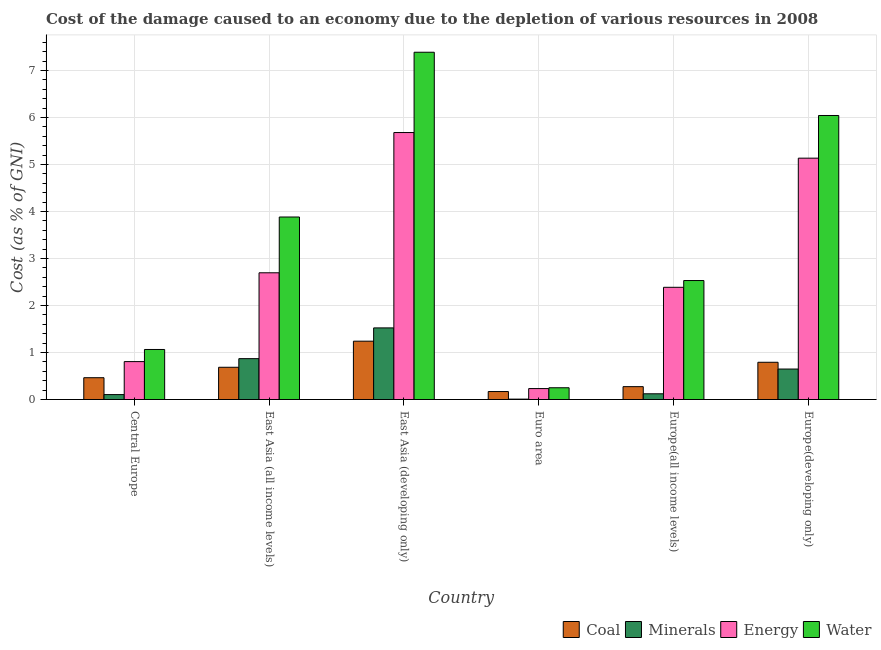How many different coloured bars are there?
Make the answer very short. 4. How many groups of bars are there?
Offer a terse response. 6. Are the number of bars on each tick of the X-axis equal?
Ensure brevity in your answer.  Yes. How many bars are there on the 5th tick from the right?
Make the answer very short. 4. What is the label of the 5th group of bars from the left?
Ensure brevity in your answer.  Europe(all income levels). What is the cost of damage due to depletion of energy in Central Europe?
Provide a succinct answer. 0.81. Across all countries, what is the maximum cost of damage due to depletion of energy?
Your answer should be very brief. 5.68. Across all countries, what is the minimum cost of damage due to depletion of minerals?
Provide a short and direct response. 0.01. In which country was the cost of damage due to depletion of energy maximum?
Keep it short and to the point. East Asia (developing only). In which country was the cost of damage due to depletion of coal minimum?
Offer a very short reply. Euro area. What is the total cost of damage due to depletion of energy in the graph?
Give a very brief answer. 16.94. What is the difference between the cost of damage due to depletion of energy in East Asia (all income levels) and that in Europe(developing only)?
Your response must be concise. -2.44. What is the difference between the cost of damage due to depletion of water in East Asia (developing only) and the cost of damage due to depletion of coal in Europe(developing only)?
Give a very brief answer. 6.6. What is the average cost of damage due to depletion of minerals per country?
Make the answer very short. 0.55. What is the difference between the cost of damage due to depletion of minerals and cost of damage due to depletion of water in Europe(all income levels)?
Provide a short and direct response. -2.41. In how many countries, is the cost of damage due to depletion of minerals greater than 0.8 %?
Your answer should be compact. 2. What is the ratio of the cost of damage due to depletion of coal in East Asia (developing only) to that in Europe(developing only)?
Provide a short and direct response. 1.57. Is the difference between the cost of damage due to depletion of minerals in East Asia (developing only) and Europe(all income levels) greater than the difference between the cost of damage due to depletion of water in East Asia (developing only) and Europe(all income levels)?
Your response must be concise. No. What is the difference between the highest and the second highest cost of damage due to depletion of coal?
Ensure brevity in your answer.  0.45. What is the difference between the highest and the lowest cost of damage due to depletion of coal?
Your answer should be compact. 1.07. Is the sum of the cost of damage due to depletion of coal in Central Europe and East Asia (all income levels) greater than the maximum cost of damage due to depletion of minerals across all countries?
Provide a short and direct response. No. Is it the case that in every country, the sum of the cost of damage due to depletion of coal and cost of damage due to depletion of energy is greater than the sum of cost of damage due to depletion of water and cost of damage due to depletion of minerals?
Give a very brief answer. No. What does the 3rd bar from the left in East Asia (developing only) represents?
Provide a short and direct response. Energy. What does the 4th bar from the right in East Asia (all income levels) represents?
Keep it short and to the point. Coal. Is it the case that in every country, the sum of the cost of damage due to depletion of coal and cost of damage due to depletion of minerals is greater than the cost of damage due to depletion of energy?
Your response must be concise. No. How many bars are there?
Your answer should be compact. 24. Are all the bars in the graph horizontal?
Offer a terse response. No. How many countries are there in the graph?
Ensure brevity in your answer.  6. What is the difference between two consecutive major ticks on the Y-axis?
Your answer should be compact. 1. Does the graph contain grids?
Your answer should be compact. Yes. Where does the legend appear in the graph?
Provide a succinct answer. Bottom right. How many legend labels are there?
Offer a very short reply. 4. How are the legend labels stacked?
Keep it short and to the point. Horizontal. What is the title of the graph?
Make the answer very short. Cost of the damage caused to an economy due to the depletion of various resources in 2008 . Does "Oil" appear as one of the legend labels in the graph?
Provide a short and direct response. No. What is the label or title of the X-axis?
Your answer should be compact. Country. What is the label or title of the Y-axis?
Ensure brevity in your answer.  Cost (as % of GNI). What is the Cost (as % of GNI) in Coal in Central Europe?
Your answer should be very brief. 0.46. What is the Cost (as % of GNI) of Minerals in Central Europe?
Your response must be concise. 0.1. What is the Cost (as % of GNI) in Energy in Central Europe?
Offer a very short reply. 0.81. What is the Cost (as % of GNI) of Water in Central Europe?
Provide a succinct answer. 1.06. What is the Cost (as % of GNI) of Coal in East Asia (all income levels)?
Offer a terse response. 0.69. What is the Cost (as % of GNI) in Minerals in East Asia (all income levels)?
Your answer should be very brief. 0.87. What is the Cost (as % of GNI) in Energy in East Asia (all income levels)?
Your answer should be compact. 2.7. What is the Cost (as % of GNI) in Water in East Asia (all income levels)?
Your answer should be compact. 3.88. What is the Cost (as % of GNI) of Coal in East Asia (developing only)?
Your answer should be very brief. 1.24. What is the Cost (as % of GNI) in Minerals in East Asia (developing only)?
Your answer should be compact. 1.52. What is the Cost (as % of GNI) in Energy in East Asia (developing only)?
Your answer should be compact. 5.68. What is the Cost (as % of GNI) of Water in East Asia (developing only)?
Your answer should be very brief. 7.39. What is the Cost (as % of GNI) of Coal in Euro area?
Make the answer very short. 0.17. What is the Cost (as % of GNI) in Minerals in Euro area?
Your response must be concise. 0.01. What is the Cost (as % of GNI) in Energy in Euro area?
Offer a very short reply. 0.23. What is the Cost (as % of GNI) in Water in Euro area?
Offer a terse response. 0.25. What is the Cost (as % of GNI) of Coal in Europe(all income levels)?
Ensure brevity in your answer.  0.27. What is the Cost (as % of GNI) in Minerals in Europe(all income levels)?
Make the answer very short. 0.12. What is the Cost (as % of GNI) in Energy in Europe(all income levels)?
Offer a terse response. 2.39. What is the Cost (as % of GNI) of Water in Europe(all income levels)?
Give a very brief answer. 2.53. What is the Cost (as % of GNI) in Coal in Europe(developing only)?
Your answer should be compact. 0.79. What is the Cost (as % of GNI) of Minerals in Europe(developing only)?
Make the answer very short. 0.65. What is the Cost (as % of GNI) in Energy in Europe(developing only)?
Your response must be concise. 5.14. What is the Cost (as % of GNI) in Water in Europe(developing only)?
Make the answer very short. 6.04. Across all countries, what is the maximum Cost (as % of GNI) of Coal?
Ensure brevity in your answer.  1.24. Across all countries, what is the maximum Cost (as % of GNI) in Minerals?
Provide a short and direct response. 1.52. Across all countries, what is the maximum Cost (as % of GNI) in Energy?
Offer a terse response. 5.68. Across all countries, what is the maximum Cost (as % of GNI) of Water?
Provide a succinct answer. 7.39. Across all countries, what is the minimum Cost (as % of GNI) of Coal?
Offer a terse response. 0.17. Across all countries, what is the minimum Cost (as % of GNI) in Minerals?
Your response must be concise. 0.01. Across all countries, what is the minimum Cost (as % of GNI) of Energy?
Provide a short and direct response. 0.23. Across all countries, what is the minimum Cost (as % of GNI) of Water?
Provide a succinct answer. 0.25. What is the total Cost (as % of GNI) of Coal in the graph?
Provide a succinct answer. 3.63. What is the total Cost (as % of GNI) in Minerals in the graph?
Offer a very short reply. 3.28. What is the total Cost (as % of GNI) in Energy in the graph?
Keep it short and to the point. 16.94. What is the total Cost (as % of GNI) in Water in the graph?
Provide a succinct answer. 21.16. What is the difference between the Cost (as % of GNI) of Coal in Central Europe and that in East Asia (all income levels)?
Provide a short and direct response. -0.22. What is the difference between the Cost (as % of GNI) in Minerals in Central Europe and that in East Asia (all income levels)?
Provide a succinct answer. -0.76. What is the difference between the Cost (as % of GNI) in Energy in Central Europe and that in East Asia (all income levels)?
Your answer should be compact. -1.89. What is the difference between the Cost (as % of GNI) in Water in Central Europe and that in East Asia (all income levels)?
Offer a terse response. -2.82. What is the difference between the Cost (as % of GNI) in Coal in Central Europe and that in East Asia (developing only)?
Make the answer very short. -0.78. What is the difference between the Cost (as % of GNI) of Minerals in Central Europe and that in East Asia (developing only)?
Keep it short and to the point. -1.42. What is the difference between the Cost (as % of GNI) of Energy in Central Europe and that in East Asia (developing only)?
Your answer should be very brief. -4.87. What is the difference between the Cost (as % of GNI) in Water in Central Europe and that in East Asia (developing only)?
Provide a succinct answer. -6.33. What is the difference between the Cost (as % of GNI) in Coal in Central Europe and that in Euro area?
Provide a succinct answer. 0.29. What is the difference between the Cost (as % of GNI) in Minerals in Central Europe and that in Euro area?
Your answer should be compact. 0.1. What is the difference between the Cost (as % of GNI) of Energy in Central Europe and that in Euro area?
Make the answer very short. 0.57. What is the difference between the Cost (as % of GNI) of Water in Central Europe and that in Euro area?
Offer a very short reply. 0.81. What is the difference between the Cost (as % of GNI) of Coal in Central Europe and that in Europe(all income levels)?
Offer a very short reply. 0.19. What is the difference between the Cost (as % of GNI) of Minerals in Central Europe and that in Europe(all income levels)?
Your answer should be very brief. -0.02. What is the difference between the Cost (as % of GNI) of Energy in Central Europe and that in Europe(all income levels)?
Provide a short and direct response. -1.58. What is the difference between the Cost (as % of GNI) of Water in Central Europe and that in Europe(all income levels)?
Your answer should be very brief. -1.47. What is the difference between the Cost (as % of GNI) in Coal in Central Europe and that in Europe(developing only)?
Ensure brevity in your answer.  -0.33. What is the difference between the Cost (as % of GNI) of Minerals in Central Europe and that in Europe(developing only)?
Keep it short and to the point. -0.54. What is the difference between the Cost (as % of GNI) of Energy in Central Europe and that in Europe(developing only)?
Offer a very short reply. -4.33. What is the difference between the Cost (as % of GNI) in Water in Central Europe and that in Europe(developing only)?
Provide a succinct answer. -4.98. What is the difference between the Cost (as % of GNI) in Coal in East Asia (all income levels) and that in East Asia (developing only)?
Provide a short and direct response. -0.56. What is the difference between the Cost (as % of GNI) of Minerals in East Asia (all income levels) and that in East Asia (developing only)?
Provide a short and direct response. -0.65. What is the difference between the Cost (as % of GNI) in Energy in East Asia (all income levels) and that in East Asia (developing only)?
Your answer should be compact. -2.98. What is the difference between the Cost (as % of GNI) in Water in East Asia (all income levels) and that in East Asia (developing only)?
Keep it short and to the point. -3.51. What is the difference between the Cost (as % of GNI) in Coal in East Asia (all income levels) and that in Euro area?
Ensure brevity in your answer.  0.52. What is the difference between the Cost (as % of GNI) in Minerals in East Asia (all income levels) and that in Euro area?
Your answer should be compact. 0.86. What is the difference between the Cost (as % of GNI) of Energy in East Asia (all income levels) and that in Euro area?
Make the answer very short. 2.46. What is the difference between the Cost (as % of GNI) of Water in East Asia (all income levels) and that in Euro area?
Provide a short and direct response. 3.63. What is the difference between the Cost (as % of GNI) in Coal in East Asia (all income levels) and that in Europe(all income levels)?
Ensure brevity in your answer.  0.41. What is the difference between the Cost (as % of GNI) in Minerals in East Asia (all income levels) and that in Europe(all income levels)?
Make the answer very short. 0.75. What is the difference between the Cost (as % of GNI) of Energy in East Asia (all income levels) and that in Europe(all income levels)?
Ensure brevity in your answer.  0.31. What is the difference between the Cost (as % of GNI) of Water in East Asia (all income levels) and that in Europe(all income levels)?
Your answer should be compact. 1.35. What is the difference between the Cost (as % of GNI) in Coal in East Asia (all income levels) and that in Europe(developing only)?
Your answer should be compact. -0.11. What is the difference between the Cost (as % of GNI) in Minerals in East Asia (all income levels) and that in Europe(developing only)?
Your response must be concise. 0.22. What is the difference between the Cost (as % of GNI) in Energy in East Asia (all income levels) and that in Europe(developing only)?
Your answer should be compact. -2.44. What is the difference between the Cost (as % of GNI) of Water in East Asia (all income levels) and that in Europe(developing only)?
Your answer should be compact. -2.16. What is the difference between the Cost (as % of GNI) in Coal in East Asia (developing only) and that in Euro area?
Offer a terse response. 1.07. What is the difference between the Cost (as % of GNI) of Minerals in East Asia (developing only) and that in Euro area?
Give a very brief answer. 1.52. What is the difference between the Cost (as % of GNI) of Energy in East Asia (developing only) and that in Euro area?
Offer a very short reply. 5.45. What is the difference between the Cost (as % of GNI) of Water in East Asia (developing only) and that in Euro area?
Your response must be concise. 7.14. What is the difference between the Cost (as % of GNI) of Coal in East Asia (developing only) and that in Europe(all income levels)?
Your response must be concise. 0.97. What is the difference between the Cost (as % of GNI) in Minerals in East Asia (developing only) and that in Europe(all income levels)?
Offer a very short reply. 1.4. What is the difference between the Cost (as % of GNI) in Energy in East Asia (developing only) and that in Europe(all income levels)?
Your answer should be compact. 3.29. What is the difference between the Cost (as % of GNI) of Water in East Asia (developing only) and that in Europe(all income levels)?
Offer a very short reply. 4.86. What is the difference between the Cost (as % of GNI) of Coal in East Asia (developing only) and that in Europe(developing only)?
Your response must be concise. 0.45. What is the difference between the Cost (as % of GNI) in Minerals in East Asia (developing only) and that in Europe(developing only)?
Keep it short and to the point. 0.88. What is the difference between the Cost (as % of GNI) in Energy in East Asia (developing only) and that in Europe(developing only)?
Your answer should be very brief. 0.55. What is the difference between the Cost (as % of GNI) of Water in East Asia (developing only) and that in Europe(developing only)?
Provide a short and direct response. 1.35. What is the difference between the Cost (as % of GNI) of Coal in Euro area and that in Europe(all income levels)?
Your answer should be compact. -0.1. What is the difference between the Cost (as % of GNI) of Minerals in Euro area and that in Europe(all income levels)?
Provide a short and direct response. -0.11. What is the difference between the Cost (as % of GNI) of Energy in Euro area and that in Europe(all income levels)?
Keep it short and to the point. -2.16. What is the difference between the Cost (as % of GNI) in Water in Euro area and that in Europe(all income levels)?
Give a very brief answer. -2.28. What is the difference between the Cost (as % of GNI) of Coal in Euro area and that in Europe(developing only)?
Your response must be concise. -0.62. What is the difference between the Cost (as % of GNI) of Minerals in Euro area and that in Europe(developing only)?
Offer a terse response. -0.64. What is the difference between the Cost (as % of GNI) in Energy in Euro area and that in Europe(developing only)?
Your response must be concise. -4.9. What is the difference between the Cost (as % of GNI) of Water in Euro area and that in Europe(developing only)?
Your response must be concise. -5.79. What is the difference between the Cost (as % of GNI) of Coal in Europe(all income levels) and that in Europe(developing only)?
Provide a short and direct response. -0.52. What is the difference between the Cost (as % of GNI) in Minerals in Europe(all income levels) and that in Europe(developing only)?
Offer a very short reply. -0.53. What is the difference between the Cost (as % of GNI) in Energy in Europe(all income levels) and that in Europe(developing only)?
Your answer should be very brief. -2.75. What is the difference between the Cost (as % of GNI) in Water in Europe(all income levels) and that in Europe(developing only)?
Provide a succinct answer. -3.51. What is the difference between the Cost (as % of GNI) of Coal in Central Europe and the Cost (as % of GNI) of Minerals in East Asia (all income levels)?
Provide a short and direct response. -0.41. What is the difference between the Cost (as % of GNI) in Coal in Central Europe and the Cost (as % of GNI) in Energy in East Asia (all income levels)?
Your response must be concise. -2.23. What is the difference between the Cost (as % of GNI) in Coal in Central Europe and the Cost (as % of GNI) in Water in East Asia (all income levels)?
Provide a succinct answer. -3.42. What is the difference between the Cost (as % of GNI) in Minerals in Central Europe and the Cost (as % of GNI) in Energy in East Asia (all income levels)?
Ensure brevity in your answer.  -2.59. What is the difference between the Cost (as % of GNI) of Minerals in Central Europe and the Cost (as % of GNI) of Water in East Asia (all income levels)?
Ensure brevity in your answer.  -3.78. What is the difference between the Cost (as % of GNI) in Energy in Central Europe and the Cost (as % of GNI) in Water in East Asia (all income levels)?
Keep it short and to the point. -3.08. What is the difference between the Cost (as % of GNI) in Coal in Central Europe and the Cost (as % of GNI) in Minerals in East Asia (developing only)?
Ensure brevity in your answer.  -1.06. What is the difference between the Cost (as % of GNI) in Coal in Central Europe and the Cost (as % of GNI) in Energy in East Asia (developing only)?
Keep it short and to the point. -5.22. What is the difference between the Cost (as % of GNI) in Coal in Central Europe and the Cost (as % of GNI) in Water in East Asia (developing only)?
Make the answer very short. -6.93. What is the difference between the Cost (as % of GNI) of Minerals in Central Europe and the Cost (as % of GNI) of Energy in East Asia (developing only)?
Your response must be concise. -5.58. What is the difference between the Cost (as % of GNI) in Minerals in Central Europe and the Cost (as % of GNI) in Water in East Asia (developing only)?
Offer a terse response. -7.29. What is the difference between the Cost (as % of GNI) of Energy in Central Europe and the Cost (as % of GNI) of Water in East Asia (developing only)?
Offer a very short reply. -6.58. What is the difference between the Cost (as % of GNI) in Coal in Central Europe and the Cost (as % of GNI) in Minerals in Euro area?
Provide a short and direct response. 0.46. What is the difference between the Cost (as % of GNI) of Coal in Central Europe and the Cost (as % of GNI) of Energy in Euro area?
Offer a very short reply. 0.23. What is the difference between the Cost (as % of GNI) of Coal in Central Europe and the Cost (as % of GNI) of Water in Euro area?
Offer a terse response. 0.21. What is the difference between the Cost (as % of GNI) in Minerals in Central Europe and the Cost (as % of GNI) in Energy in Euro area?
Offer a very short reply. -0.13. What is the difference between the Cost (as % of GNI) in Minerals in Central Europe and the Cost (as % of GNI) in Water in Euro area?
Your response must be concise. -0.15. What is the difference between the Cost (as % of GNI) in Energy in Central Europe and the Cost (as % of GNI) in Water in Euro area?
Keep it short and to the point. 0.56. What is the difference between the Cost (as % of GNI) of Coal in Central Europe and the Cost (as % of GNI) of Minerals in Europe(all income levels)?
Offer a terse response. 0.34. What is the difference between the Cost (as % of GNI) in Coal in Central Europe and the Cost (as % of GNI) in Energy in Europe(all income levels)?
Keep it short and to the point. -1.92. What is the difference between the Cost (as % of GNI) in Coal in Central Europe and the Cost (as % of GNI) in Water in Europe(all income levels)?
Provide a short and direct response. -2.07. What is the difference between the Cost (as % of GNI) in Minerals in Central Europe and the Cost (as % of GNI) in Energy in Europe(all income levels)?
Provide a succinct answer. -2.28. What is the difference between the Cost (as % of GNI) of Minerals in Central Europe and the Cost (as % of GNI) of Water in Europe(all income levels)?
Make the answer very short. -2.43. What is the difference between the Cost (as % of GNI) in Energy in Central Europe and the Cost (as % of GNI) in Water in Europe(all income levels)?
Your answer should be compact. -1.73. What is the difference between the Cost (as % of GNI) in Coal in Central Europe and the Cost (as % of GNI) in Minerals in Europe(developing only)?
Offer a very short reply. -0.18. What is the difference between the Cost (as % of GNI) of Coal in Central Europe and the Cost (as % of GNI) of Energy in Europe(developing only)?
Ensure brevity in your answer.  -4.67. What is the difference between the Cost (as % of GNI) in Coal in Central Europe and the Cost (as % of GNI) in Water in Europe(developing only)?
Offer a very short reply. -5.58. What is the difference between the Cost (as % of GNI) in Minerals in Central Europe and the Cost (as % of GNI) in Energy in Europe(developing only)?
Ensure brevity in your answer.  -5.03. What is the difference between the Cost (as % of GNI) in Minerals in Central Europe and the Cost (as % of GNI) in Water in Europe(developing only)?
Ensure brevity in your answer.  -5.94. What is the difference between the Cost (as % of GNI) in Energy in Central Europe and the Cost (as % of GNI) in Water in Europe(developing only)?
Your answer should be very brief. -5.24. What is the difference between the Cost (as % of GNI) in Coal in East Asia (all income levels) and the Cost (as % of GNI) in Minerals in East Asia (developing only)?
Offer a terse response. -0.84. What is the difference between the Cost (as % of GNI) in Coal in East Asia (all income levels) and the Cost (as % of GNI) in Energy in East Asia (developing only)?
Offer a very short reply. -5. What is the difference between the Cost (as % of GNI) of Coal in East Asia (all income levels) and the Cost (as % of GNI) of Water in East Asia (developing only)?
Your answer should be compact. -6.7. What is the difference between the Cost (as % of GNI) in Minerals in East Asia (all income levels) and the Cost (as % of GNI) in Energy in East Asia (developing only)?
Your answer should be very brief. -4.81. What is the difference between the Cost (as % of GNI) in Minerals in East Asia (all income levels) and the Cost (as % of GNI) in Water in East Asia (developing only)?
Offer a terse response. -6.52. What is the difference between the Cost (as % of GNI) of Energy in East Asia (all income levels) and the Cost (as % of GNI) of Water in East Asia (developing only)?
Give a very brief answer. -4.69. What is the difference between the Cost (as % of GNI) of Coal in East Asia (all income levels) and the Cost (as % of GNI) of Minerals in Euro area?
Your answer should be compact. 0.68. What is the difference between the Cost (as % of GNI) in Coal in East Asia (all income levels) and the Cost (as % of GNI) in Energy in Euro area?
Provide a succinct answer. 0.45. What is the difference between the Cost (as % of GNI) of Coal in East Asia (all income levels) and the Cost (as % of GNI) of Water in Euro area?
Your answer should be compact. 0.44. What is the difference between the Cost (as % of GNI) of Minerals in East Asia (all income levels) and the Cost (as % of GNI) of Energy in Euro area?
Your response must be concise. 0.64. What is the difference between the Cost (as % of GNI) in Minerals in East Asia (all income levels) and the Cost (as % of GNI) in Water in Euro area?
Provide a succinct answer. 0.62. What is the difference between the Cost (as % of GNI) of Energy in East Asia (all income levels) and the Cost (as % of GNI) of Water in Euro area?
Your response must be concise. 2.45. What is the difference between the Cost (as % of GNI) of Coal in East Asia (all income levels) and the Cost (as % of GNI) of Minerals in Europe(all income levels)?
Your answer should be very brief. 0.56. What is the difference between the Cost (as % of GNI) of Coal in East Asia (all income levels) and the Cost (as % of GNI) of Energy in Europe(all income levels)?
Give a very brief answer. -1.7. What is the difference between the Cost (as % of GNI) in Coal in East Asia (all income levels) and the Cost (as % of GNI) in Water in Europe(all income levels)?
Keep it short and to the point. -1.85. What is the difference between the Cost (as % of GNI) of Minerals in East Asia (all income levels) and the Cost (as % of GNI) of Energy in Europe(all income levels)?
Your response must be concise. -1.52. What is the difference between the Cost (as % of GNI) of Minerals in East Asia (all income levels) and the Cost (as % of GNI) of Water in Europe(all income levels)?
Provide a short and direct response. -1.66. What is the difference between the Cost (as % of GNI) of Energy in East Asia (all income levels) and the Cost (as % of GNI) of Water in Europe(all income levels)?
Give a very brief answer. 0.17. What is the difference between the Cost (as % of GNI) of Coal in East Asia (all income levels) and the Cost (as % of GNI) of Minerals in Europe(developing only)?
Provide a succinct answer. 0.04. What is the difference between the Cost (as % of GNI) of Coal in East Asia (all income levels) and the Cost (as % of GNI) of Energy in Europe(developing only)?
Offer a very short reply. -4.45. What is the difference between the Cost (as % of GNI) of Coal in East Asia (all income levels) and the Cost (as % of GNI) of Water in Europe(developing only)?
Provide a short and direct response. -5.36. What is the difference between the Cost (as % of GNI) of Minerals in East Asia (all income levels) and the Cost (as % of GNI) of Energy in Europe(developing only)?
Give a very brief answer. -4.27. What is the difference between the Cost (as % of GNI) of Minerals in East Asia (all income levels) and the Cost (as % of GNI) of Water in Europe(developing only)?
Offer a very short reply. -5.17. What is the difference between the Cost (as % of GNI) of Energy in East Asia (all income levels) and the Cost (as % of GNI) of Water in Europe(developing only)?
Your answer should be very brief. -3.35. What is the difference between the Cost (as % of GNI) in Coal in East Asia (developing only) and the Cost (as % of GNI) in Minerals in Euro area?
Offer a very short reply. 1.23. What is the difference between the Cost (as % of GNI) of Coal in East Asia (developing only) and the Cost (as % of GNI) of Energy in Euro area?
Give a very brief answer. 1.01. What is the difference between the Cost (as % of GNI) of Minerals in East Asia (developing only) and the Cost (as % of GNI) of Energy in Euro area?
Your answer should be compact. 1.29. What is the difference between the Cost (as % of GNI) of Minerals in East Asia (developing only) and the Cost (as % of GNI) of Water in Euro area?
Your answer should be compact. 1.27. What is the difference between the Cost (as % of GNI) of Energy in East Asia (developing only) and the Cost (as % of GNI) of Water in Euro area?
Provide a short and direct response. 5.43. What is the difference between the Cost (as % of GNI) of Coal in East Asia (developing only) and the Cost (as % of GNI) of Minerals in Europe(all income levels)?
Your answer should be compact. 1.12. What is the difference between the Cost (as % of GNI) of Coal in East Asia (developing only) and the Cost (as % of GNI) of Energy in Europe(all income levels)?
Your answer should be very brief. -1.15. What is the difference between the Cost (as % of GNI) of Coal in East Asia (developing only) and the Cost (as % of GNI) of Water in Europe(all income levels)?
Your answer should be very brief. -1.29. What is the difference between the Cost (as % of GNI) of Minerals in East Asia (developing only) and the Cost (as % of GNI) of Energy in Europe(all income levels)?
Provide a succinct answer. -0.86. What is the difference between the Cost (as % of GNI) in Minerals in East Asia (developing only) and the Cost (as % of GNI) in Water in Europe(all income levels)?
Keep it short and to the point. -1.01. What is the difference between the Cost (as % of GNI) in Energy in East Asia (developing only) and the Cost (as % of GNI) in Water in Europe(all income levels)?
Provide a short and direct response. 3.15. What is the difference between the Cost (as % of GNI) of Coal in East Asia (developing only) and the Cost (as % of GNI) of Minerals in Europe(developing only)?
Keep it short and to the point. 0.59. What is the difference between the Cost (as % of GNI) in Coal in East Asia (developing only) and the Cost (as % of GNI) in Energy in Europe(developing only)?
Make the answer very short. -3.89. What is the difference between the Cost (as % of GNI) in Coal in East Asia (developing only) and the Cost (as % of GNI) in Water in Europe(developing only)?
Ensure brevity in your answer.  -4.8. What is the difference between the Cost (as % of GNI) of Minerals in East Asia (developing only) and the Cost (as % of GNI) of Energy in Europe(developing only)?
Offer a very short reply. -3.61. What is the difference between the Cost (as % of GNI) of Minerals in East Asia (developing only) and the Cost (as % of GNI) of Water in Europe(developing only)?
Your answer should be very brief. -4.52. What is the difference between the Cost (as % of GNI) of Energy in East Asia (developing only) and the Cost (as % of GNI) of Water in Europe(developing only)?
Provide a short and direct response. -0.36. What is the difference between the Cost (as % of GNI) in Coal in Euro area and the Cost (as % of GNI) in Minerals in Europe(all income levels)?
Your answer should be very brief. 0.05. What is the difference between the Cost (as % of GNI) of Coal in Euro area and the Cost (as % of GNI) of Energy in Europe(all income levels)?
Make the answer very short. -2.22. What is the difference between the Cost (as % of GNI) of Coal in Euro area and the Cost (as % of GNI) of Water in Europe(all income levels)?
Provide a succinct answer. -2.36. What is the difference between the Cost (as % of GNI) in Minerals in Euro area and the Cost (as % of GNI) in Energy in Europe(all income levels)?
Ensure brevity in your answer.  -2.38. What is the difference between the Cost (as % of GNI) of Minerals in Euro area and the Cost (as % of GNI) of Water in Europe(all income levels)?
Your response must be concise. -2.52. What is the difference between the Cost (as % of GNI) in Energy in Euro area and the Cost (as % of GNI) in Water in Europe(all income levels)?
Your response must be concise. -2.3. What is the difference between the Cost (as % of GNI) of Coal in Euro area and the Cost (as % of GNI) of Minerals in Europe(developing only)?
Ensure brevity in your answer.  -0.48. What is the difference between the Cost (as % of GNI) of Coal in Euro area and the Cost (as % of GNI) of Energy in Europe(developing only)?
Your response must be concise. -4.97. What is the difference between the Cost (as % of GNI) of Coal in Euro area and the Cost (as % of GNI) of Water in Europe(developing only)?
Your answer should be compact. -5.87. What is the difference between the Cost (as % of GNI) in Minerals in Euro area and the Cost (as % of GNI) in Energy in Europe(developing only)?
Your answer should be compact. -5.13. What is the difference between the Cost (as % of GNI) in Minerals in Euro area and the Cost (as % of GNI) in Water in Europe(developing only)?
Give a very brief answer. -6.04. What is the difference between the Cost (as % of GNI) in Energy in Euro area and the Cost (as % of GNI) in Water in Europe(developing only)?
Make the answer very short. -5.81. What is the difference between the Cost (as % of GNI) of Coal in Europe(all income levels) and the Cost (as % of GNI) of Minerals in Europe(developing only)?
Your answer should be very brief. -0.37. What is the difference between the Cost (as % of GNI) in Coal in Europe(all income levels) and the Cost (as % of GNI) in Energy in Europe(developing only)?
Your answer should be compact. -4.86. What is the difference between the Cost (as % of GNI) in Coal in Europe(all income levels) and the Cost (as % of GNI) in Water in Europe(developing only)?
Give a very brief answer. -5.77. What is the difference between the Cost (as % of GNI) of Minerals in Europe(all income levels) and the Cost (as % of GNI) of Energy in Europe(developing only)?
Provide a succinct answer. -5.01. What is the difference between the Cost (as % of GNI) of Minerals in Europe(all income levels) and the Cost (as % of GNI) of Water in Europe(developing only)?
Provide a short and direct response. -5.92. What is the difference between the Cost (as % of GNI) in Energy in Europe(all income levels) and the Cost (as % of GNI) in Water in Europe(developing only)?
Offer a very short reply. -3.66. What is the average Cost (as % of GNI) of Coal per country?
Your answer should be very brief. 0.6. What is the average Cost (as % of GNI) of Minerals per country?
Your response must be concise. 0.55. What is the average Cost (as % of GNI) of Energy per country?
Your response must be concise. 2.82. What is the average Cost (as % of GNI) in Water per country?
Offer a very short reply. 3.53. What is the difference between the Cost (as % of GNI) in Coal and Cost (as % of GNI) in Minerals in Central Europe?
Offer a very short reply. 0.36. What is the difference between the Cost (as % of GNI) in Coal and Cost (as % of GNI) in Energy in Central Europe?
Ensure brevity in your answer.  -0.34. What is the difference between the Cost (as % of GNI) of Coal and Cost (as % of GNI) of Water in Central Europe?
Give a very brief answer. -0.6. What is the difference between the Cost (as % of GNI) in Minerals and Cost (as % of GNI) in Energy in Central Europe?
Make the answer very short. -0.7. What is the difference between the Cost (as % of GNI) in Minerals and Cost (as % of GNI) in Water in Central Europe?
Your response must be concise. -0.96. What is the difference between the Cost (as % of GNI) of Energy and Cost (as % of GNI) of Water in Central Europe?
Give a very brief answer. -0.26. What is the difference between the Cost (as % of GNI) of Coal and Cost (as % of GNI) of Minerals in East Asia (all income levels)?
Offer a terse response. -0.18. What is the difference between the Cost (as % of GNI) of Coal and Cost (as % of GNI) of Energy in East Asia (all income levels)?
Offer a terse response. -2.01. What is the difference between the Cost (as % of GNI) in Coal and Cost (as % of GNI) in Water in East Asia (all income levels)?
Offer a terse response. -3.2. What is the difference between the Cost (as % of GNI) of Minerals and Cost (as % of GNI) of Energy in East Asia (all income levels)?
Make the answer very short. -1.83. What is the difference between the Cost (as % of GNI) in Minerals and Cost (as % of GNI) in Water in East Asia (all income levels)?
Offer a terse response. -3.01. What is the difference between the Cost (as % of GNI) in Energy and Cost (as % of GNI) in Water in East Asia (all income levels)?
Offer a terse response. -1.19. What is the difference between the Cost (as % of GNI) of Coal and Cost (as % of GNI) of Minerals in East Asia (developing only)?
Your answer should be very brief. -0.28. What is the difference between the Cost (as % of GNI) in Coal and Cost (as % of GNI) in Energy in East Asia (developing only)?
Make the answer very short. -4.44. What is the difference between the Cost (as % of GNI) of Coal and Cost (as % of GNI) of Water in East Asia (developing only)?
Offer a very short reply. -6.15. What is the difference between the Cost (as % of GNI) of Minerals and Cost (as % of GNI) of Energy in East Asia (developing only)?
Your response must be concise. -4.16. What is the difference between the Cost (as % of GNI) in Minerals and Cost (as % of GNI) in Water in East Asia (developing only)?
Offer a terse response. -5.87. What is the difference between the Cost (as % of GNI) in Energy and Cost (as % of GNI) in Water in East Asia (developing only)?
Offer a very short reply. -1.71. What is the difference between the Cost (as % of GNI) in Coal and Cost (as % of GNI) in Minerals in Euro area?
Offer a very short reply. 0.16. What is the difference between the Cost (as % of GNI) in Coal and Cost (as % of GNI) in Energy in Euro area?
Offer a terse response. -0.06. What is the difference between the Cost (as % of GNI) of Coal and Cost (as % of GNI) of Water in Euro area?
Your answer should be compact. -0.08. What is the difference between the Cost (as % of GNI) in Minerals and Cost (as % of GNI) in Energy in Euro area?
Provide a short and direct response. -0.22. What is the difference between the Cost (as % of GNI) of Minerals and Cost (as % of GNI) of Water in Euro area?
Your response must be concise. -0.24. What is the difference between the Cost (as % of GNI) in Energy and Cost (as % of GNI) in Water in Euro area?
Give a very brief answer. -0.02. What is the difference between the Cost (as % of GNI) in Coal and Cost (as % of GNI) in Minerals in Europe(all income levels)?
Keep it short and to the point. 0.15. What is the difference between the Cost (as % of GNI) of Coal and Cost (as % of GNI) of Energy in Europe(all income levels)?
Your answer should be very brief. -2.11. What is the difference between the Cost (as % of GNI) of Coal and Cost (as % of GNI) of Water in Europe(all income levels)?
Offer a terse response. -2.26. What is the difference between the Cost (as % of GNI) of Minerals and Cost (as % of GNI) of Energy in Europe(all income levels)?
Provide a succinct answer. -2.27. What is the difference between the Cost (as % of GNI) of Minerals and Cost (as % of GNI) of Water in Europe(all income levels)?
Your answer should be very brief. -2.41. What is the difference between the Cost (as % of GNI) in Energy and Cost (as % of GNI) in Water in Europe(all income levels)?
Offer a very short reply. -0.14. What is the difference between the Cost (as % of GNI) of Coal and Cost (as % of GNI) of Minerals in Europe(developing only)?
Make the answer very short. 0.14. What is the difference between the Cost (as % of GNI) of Coal and Cost (as % of GNI) of Energy in Europe(developing only)?
Ensure brevity in your answer.  -4.34. What is the difference between the Cost (as % of GNI) of Coal and Cost (as % of GNI) of Water in Europe(developing only)?
Provide a succinct answer. -5.25. What is the difference between the Cost (as % of GNI) in Minerals and Cost (as % of GNI) in Energy in Europe(developing only)?
Ensure brevity in your answer.  -4.49. What is the difference between the Cost (as % of GNI) in Minerals and Cost (as % of GNI) in Water in Europe(developing only)?
Your response must be concise. -5.4. What is the difference between the Cost (as % of GNI) in Energy and Cost (as % of GNI) in Water in Europe(developing only)?
Your response must be concise. -0.91. What is the ratio of the Cost (as % of GNI) of Coal in Central Europe to that in East Asia (all income levels)?
Give a very brief answer. 0.68. What is the ratio of the Cost (as % of GNI) of Minerals in Central Europe to that in East Asia (all income levels)?
Keep it short and to the point. 0.12. What is the ratio of the Cost (as % of GNI) in Energy in Central Europe to that in East Asia (all income levels)?
Offer a very short reply. 0.3. What is the ratio of the Cost (as % of GNI) in Water in Central Europe to that in East Asia (all income levels)?
Make the answer very short. 0.27. What is the ratio of the Cost (as % of GNI) in Coal in Central Europe to that in East Asia (developing only)?
Make the answer very short. 0.37. What is the ratio of the Cost (as % of GNI) in Minerals in Central Europe to that in East Asia (developing only)?
Offer a very short reply. 0.07. What is the ratio of the Cost (as % of GNI) of Energy in Central Europe to that in East Asia (developing only)?
Your response must be concise. 0.14. What is the ratio of the Cost (as % of GNI) of Water in Central Europe to that in East Asia (developing only)?
Your response must be concise. 0.14. What is the ratio of the Cost (as % of GNI) of Coal in Central Europe to that in Euro area?
Offer a very short reply. 2.73. What is the ratio of the Cost (as % of GNI) in Minerals in Central Europe to that in Euro area?
Keep it short and to the point. 12.45. What is the ratio of the Cost (as % of GNI) of Energy in Central Europe to that in Euro area?
Your response must be concise. 3.46. What is the ratio of the Cost (as % of GNI) in Water in Central Europe to that in Euro area?
Offer a very short reply. 4.25. What is the ratio of the Cost (as % of GNI) of Coal in Central Europe to that in Europe(all income levels)?
Your response must be concise. 1.69. What is the ratio of the Cost (as % of GNI) of Minerals in Central Europe to that in Europe(all income levels)?
Your answer should be very brief. 0.86. What is the ratio of the Cost (as % of GNI) of Energy in Central Europe to that in Europe(all income levels)?
Your response must be concise. 0.34. What is the ratio of the Cost (as % of GNI) in Water in Central Europe to that in Europe(all income levels)?
Keep it short and to the point. 0.42. What is the ratio of the Cost (as % of GNI) of Coal in Central Europe to that in Europe(developing only)?
Offer a very short reply. 0.59. What is the ratio of the Cost (as % of GNI) of Minerals in Central Europe to that in Europe(developing only)?
Your answer should be very brief. 0.16. What is the ratio of the Cost (as % of GNI) of Energy in Central Europe to that in Europe(developing only)?
Ensure brevity in your answer.  0.16. What is the ratio of the Cost (as % of GNI) in Water in Central Europe to that in Europe(developing only)?
Offer a very short reply. 0.18. What is the ratio of the Cost (as % of GNI) in Coal in East Asia (all income levels) to that in East Asia (developing only)?
Your response must be concise. 0.55. What is the ratio of the Cost (as % of GNI) in Minerals in East Asia (all income levels) to that in East Asia (developing only)?
Offer a very short reply. 0.57. What is the ratio of the Cost (as % of GNI) in Energy in East Asia (all income levels) to that in East Asia (developing only)?
Your answer should be compact. 0.47. What is the ratio of the Cost (as % of GNI) in Water in East Asia (all income levels) to that in East Asia (developing only)?
Your response must be concise. 0.53. What is the ratio of the Cost (as % of GNI) of Coal in East Asia (all income levels) to that in Euro area?
Provide a short and direct response. 4.04. What is the ratio of the Cost (as % of GNI) of Minerals in East Asia (all income levels) to that in Euro area?
Your answer should be compact. 103.18. What is the ratio of the Cost (as % of GNI) of Energy in East Asia (all income levels) to that in Euro area?
Offer a terse response. 11.58. What is the ratio of the Cost (as % of GNI) in Water in East Asia (all income levels) to that in Euro area?
Offer a very short reply. 15.52. What is the ratio of the Cost (as % of GNI) of Coal in East Asia (all income levels) to that in Europe(all income levels)?
Keep it short and to the point. 2.5. What is the ratio of the Cost (as % of GNI) of Minerals in East Asia (all income levels) to that in Europe(all income levels)?
Provide a succinct answer. 7.13. What is the ratio of the Cost (as % of GNI) of Energy in East Asia (all income levels) to that in Europe(all income levels)?
Keep it short and to the point. 1.13. What is the ratio of the Cost (as % of GNI) of Water in East Asia (all income levels) to that in Europe(all income levels)?
Provide a short and direct response. 1.53. What is the ratio of the Cost (as % of GNI) of Coal in East Asia (all income levels) to that in Europe(developing only)?
Your response must be concise. 0.87. What is the ratio of the Cost (as % of GNI) of Minerals in East Asia (all income levels) to that in Europe(developing only)?
Give a very brief answer. 1.34. What is the ratio of the Cost (as % of GNI) in Energy in East Asia (all income levels) to that in Europe(developing only)?
Make the answer very short. 0.53. What is the ratio of the Cost (as % of GNI) in Water in East Asia (all income levels) to that in Europe(developing only)?
Keep it short and to the point. 0.64. What is the ratio of the Cost (as % of GNI) in Coal in East Asia (developing only) to that in Euro area?
Keep it short and to the point. 7.31. What is the ratio of the Cost (as % of GNI) in Minerals in East Asia (developing only) to that in Euro area?
Offer a terse response. 180.84. What is the ratio of the Cost (as % of GNI) of Energy in East Asia (developing only) to that in Euro area?
Your answer should be very brief. 24.39. What is the ratio of the Cost (as % of GNI) in Water in East Asia (developing only) to that in Euro area?
Your answer should be very brief. 29.52. What is the ratio of the Cost (as % of GNI) of Coal in East Asia (developing only) to that in Europe(all income levels)?
Make the answer very short. 4.53. What is the ratio of the Cost (as % of GNI) of Minerals in East Asia (developing only) to that in Europe(all income levels)?
Ensure brevity in your answer.  12.5. What is the ratio of the Cost (as % of GNI) of Energy in East Asia (developing only) to that in Europe(all income levels)?
Provide a succinct answer. 2.38. What is the ratio of the Cost (as % of GNI) in Water in East Asia (developing only) to that in Europe(all income levels)?
Your response must be concise. 2.92. What is the ratio of the Cost (as % of GNI) of Coal in East Asia (developing only) to that in Europe(developing only)?
Make the answer very short. 1.57. What is the ratio of the Cost (as % of GNI) in Minerals in East Asia (developing only) to that in Europe(developing only)?
Offer a terse response. 2.35. What is the ratio of the Cost (as % of GNI) in Energy in East Asia (developing only) to that in Europe(developing only)?
Offer a terse response. 1.11. What is the ratio of the Cost (as % of GNI) in Water in East Asia (developing only) to that in Europe(developing only)?
Your response must be concise. 1.22. What is the ratio of the Cost (as % of GNI) of Coal in Euro area to that in Europe(all income levels)?
Offer a very short reply. 0.62. What is the ratio of the Cost (as % of GNI) in Minerals in Euro area to that in Europe(all income levels)?
Provide a succinct answer. 0.07. What is the ratio of the Cost (as % of GNI) in Energy in Euro area to that in Europe(all income levels)?
Provide a succinct answer. 0.1. What is the ratio of the Cost (as % of GNI) of Water in Euro area to that in Europe(all income levels)?
Give a very brief answer. 0.1. What is the ratio of the Cost (as % of GNI) in Coal in Euro area to that in Europe(developing only)?
Ensure brevity in your answer.  0.21. What is the ratio of the Cost (as % of GNI) of Minerals in Euro area to that in Europe(developing only)?
Provide a succinct answer. 0.01. What is the ratio of the Cost (as % of GNI) in Energy in Euro area to that in Europe(developing only)?
Offer a very short reply. 0.05. What is the ratio of the Cost (as % of GNI) of Water in Euro area to that in Europe(developing only)?
Your answer should be very brief. 0.04. What is the ratio of the Cost (as % of GNI) of Coal in Europe(all income levels) to that in Europe(developing only)?
Your answer should be very brief. 0.35. What is the ratio of the Cost (as % of GNI) of Minerals in Europe(all income levels) to that in Europe(developing only)?
Offer a very short reply. 0.19. What is the ratio of the Cost (as % of GNI) in Energy in Europe(all income levels) to that in Europe(developing only)?
Your answer should be very brief. 0.47. What is the ratio of the Cost (as % of GNI) in Water in Europe(all income levels) to that in Europe(developing only)?
Ensure brevity in your answer.  0.42. What is the difference between the highest and the second highest Cost (as % of GNI) in Coal?
Offer a very short reply. 0.45. What is the difference between the highest and the second highest Cost (as % of GNI) of Minerals?
Your answer should be very brief. 0.65. What is the difference between the highest and the second highest Cost (as % of GNI) in Energy?
Your response must be concise. 0.55. What is the difference between the highest and the second highest Cost (as % of GNI) in Water?
Ensure brevity in your answer.  1.35. What is the difference between the highest and the lowest Cost (as % of GNI) of Coal?
Your answer should be compact. 1.07. What is the difference between the highest and the lowest Cost (as % of GNI) of Minerals?
Offer a very short reply. 1.52. What is the difference between the highest and the lowest Cost (as % of GNI) in Energy?
Ensure brevity in your answer.  5.45. What is the difference between the highest and the lowest Cost (as % of GNI) in Water?
Offer a terse response. 7.14. 